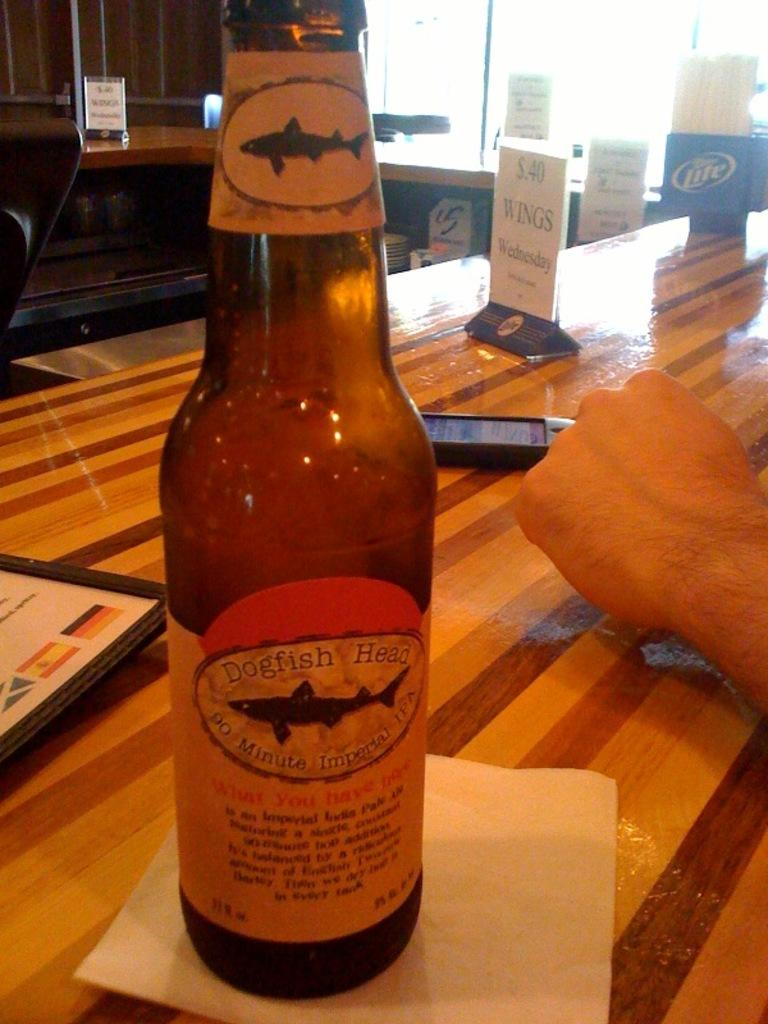<image>
Describe the image concisely. A boottle of Dogfish Head beer is on a napkin on a table. 